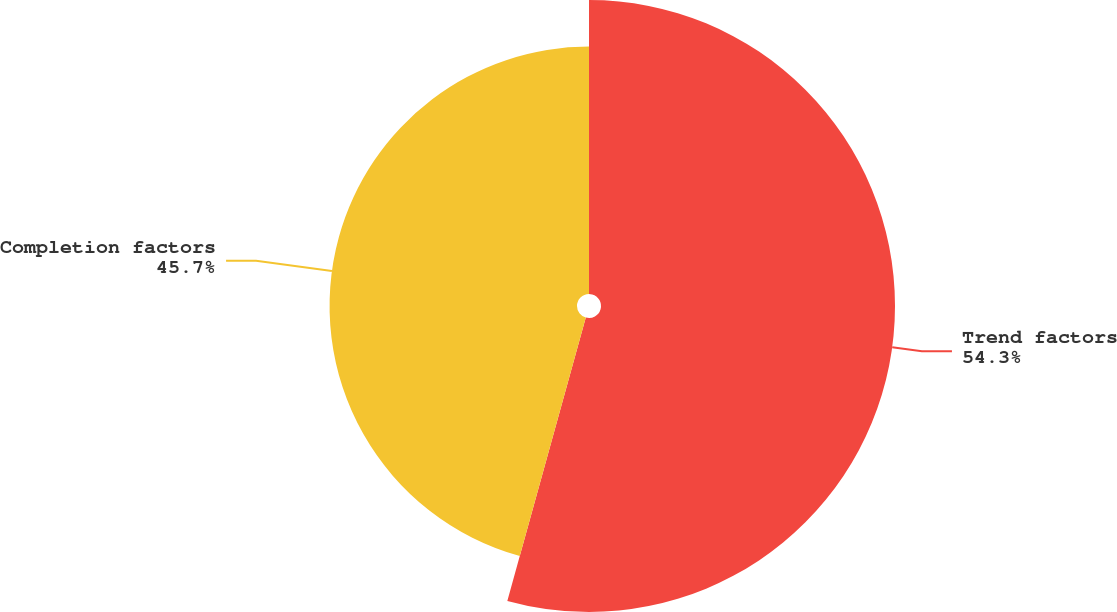Convert chart. <chart><loc_0><loc_0><loc_500><loc_500><pie_chart><fcel>Trend factors<fcel>Completion factors<nl><fcel>54.3%<fcel>45.7%<nl></chart> 